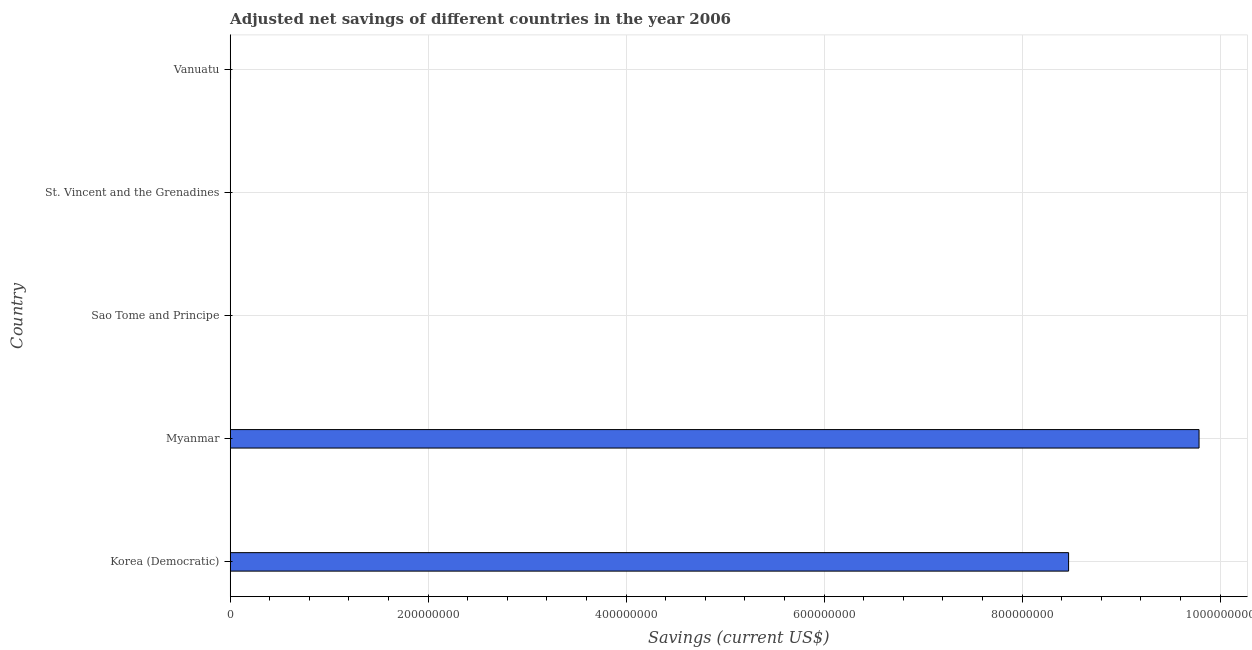What is the title of the graph?
Keep it short and to the point. Adjusted net savings of different countries in the year 2006. What is the label or title of the X-axis?
Keep it short and to the point. Savings (current US$). What is the adjusted net savings in Myanmar?
Your answer should be compact. 9.79e+08. Across all countries, what is the maximum adjusted net savings?
Provide a succinct answer. 9.79e+08. Across all countries, what is the minimum adjusted net savings?
Your response must be concise. 1.21e+04. In which country was the adjusted net savings maximum?
Ensure brevity in your answer.  Myanmar. In which country was the adjusted net savings minimum?
Offer a terse response. Sao Tome and Principe. What is the sum of the adjusted net savings?
Your answer should be very brief. 1.83e+09. What is the difference between the adjusted net savings in Sao Tome and Principe and Vanuatu?
Provide a short and direct response. -3.58e+05. What is the average adjusted net savings per country?
Ensure brevity in your answer.  3.65e+08. What is the median adjusted net savings?
Your response must be concise. 3.70e+05. What is the ratio of the adjusted net savings in Korea (Democratic) to that in Vanuatu?
Ensure brevity in your answer.  2287.25. Is the adjusted net savings in Myanmar less than that in Vanuatu?
Provide a short and direct response. No. Is the difference between the adjusted net savings in Myanmar and Sao Tome and Principe greater than the difference between any two countries?
Your response must be concise. Yes. What is the difference between the highest and the second highest adjusted net savings?
Give a very brief answer. 1.32e+08. What is the difference between the highest and the lowest adjusted net savings?
Keep it short and to the point. 9.79e+08. How many bars are there?
Your response must be concise. 5. Are all the bars in the graph horizontal?
Your answer should be compact. Yes. How many countries are there in the graph?
Provide a succinct answer. 5. Are the values on the major ticks of X-axis written in scientific E-notation?
Provide a succinct answer. No. What is the Savings (current US$) in Korea (Democratic)?
Make the answer very short. 8.47e+08. What is the Savings (current US$) of Myanmar?
Provide a short and direct response. 9.79e+08. What is the Savings (current US$) of Sao Tome and Principe?
Provide a short and direct response. 1.21e+04. What is the Savings (current US$) in St. Vincent and the Grenadines?
Provide a short and direct response. 4.45e+04. What is the Savings (current US$) of Vanuatu?
Your answer should be very brief. 3.70e+05. What is the difference between the Savings (current US$) in Korea (Democratic) and Myanmar?
Offer a terse response. -1.32e+08. What is the difference between the Savings (current US$) in Korea (Democratic) and Sao Tome and Principe?
Provide a succinct answer. 8.47e+08. What is the difference between the Savings (current US$) in Korea (Democratic) and St. Vincent and the Grenadines?
Offer a terse response. 8.47e+08. What is the difference between the Savings (current US$) in Korea (Democratic) and Vanuatu?
Give a very brief answer. 8.47e+08. What is the difference between the Savings (current US$) in Myanmar and Sao Tome and Principe?
Offer a terse response. 9.79e+08. What is the difference between the Savings (current US$) in Myanmar and St. Vincent and the Grenadines?
Offer a very short reply. 9.79e+08. What is the difference between the Savings (current US$) in Myanmar and Vanuatu?
Ensure brevity in your answer.  9.78e+08. What is the difference between the Savings (current US$) in Sao Tome and Principe and St. Vincent and the Grenadines?
Your answer should be compact. -3.24e+04. What is the difference between the Savings (current US$) in Sao Tome and Principe and Vanuatu?
Give a very brief answer. -3.58e+05. What is the difference between the Savings (current US$) in St. Vincent and the Grenadines and Vanuatu?
Keep it short and to the point. -3.26e+05. What is the ratio of the Savings (current US$) in Korea (Democratic) to that in Myanmar?
Your answer should be compact. 0.86. What is the ratio of the Savings (current US$) in Korea (Democratic) to that in Sao Tome and Principe?
Offer a terse response. 6.99e+04. What is the ratio of the Savings (current US$) in Korea (Democratic) to that in St. Vincent and the Grenadines?
Give a very brief answer. 1.90e+04. What is the ratio of the Savings (current US$) in Korea (Democratic) to that in Vanuatu?
Offer a terse response. 2287.25. What is the ratio of the Savings (current US$) in Myanmar to that in Sao Tome and Principe?
Give a very brief answer. 8.08e+04. What is the ratio of the Savings (current US$) in Myanmar to that in St. Vincent and the Grenadines?
Keep it short and to the point. 2.20e+04. What is the ratio of the Savings (current US$) in Myanmar to that in Vanuatu?
Give a very brief answer. 2643.14. What is the ratio of the Savings (current US$) in Sao Tome and Principe to that in St. Vincent and the Grenadines?
Provide a succinct answer. 0.27. What is the ratio of the Savings (current US$) in Sao Tome and Principe to that in Vanuatu?
Keep it short and to the point. 0.03. What is the ratio of the Savings (current US$) in St. Vincent and the Grenadines to that in Vanuatu?
Ensure brevity in your answer.  0.12. 